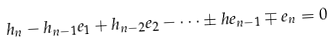<formula> <loc_0><loc_0><loc_500><loc_500>h _ { n } - h _ { n - 1 } e _ { 1 } + h _ { n - 2 } e _ { 2 } - \dots \pm h e _ { n - 1 } \mp e _ { n } = 0</formula> 